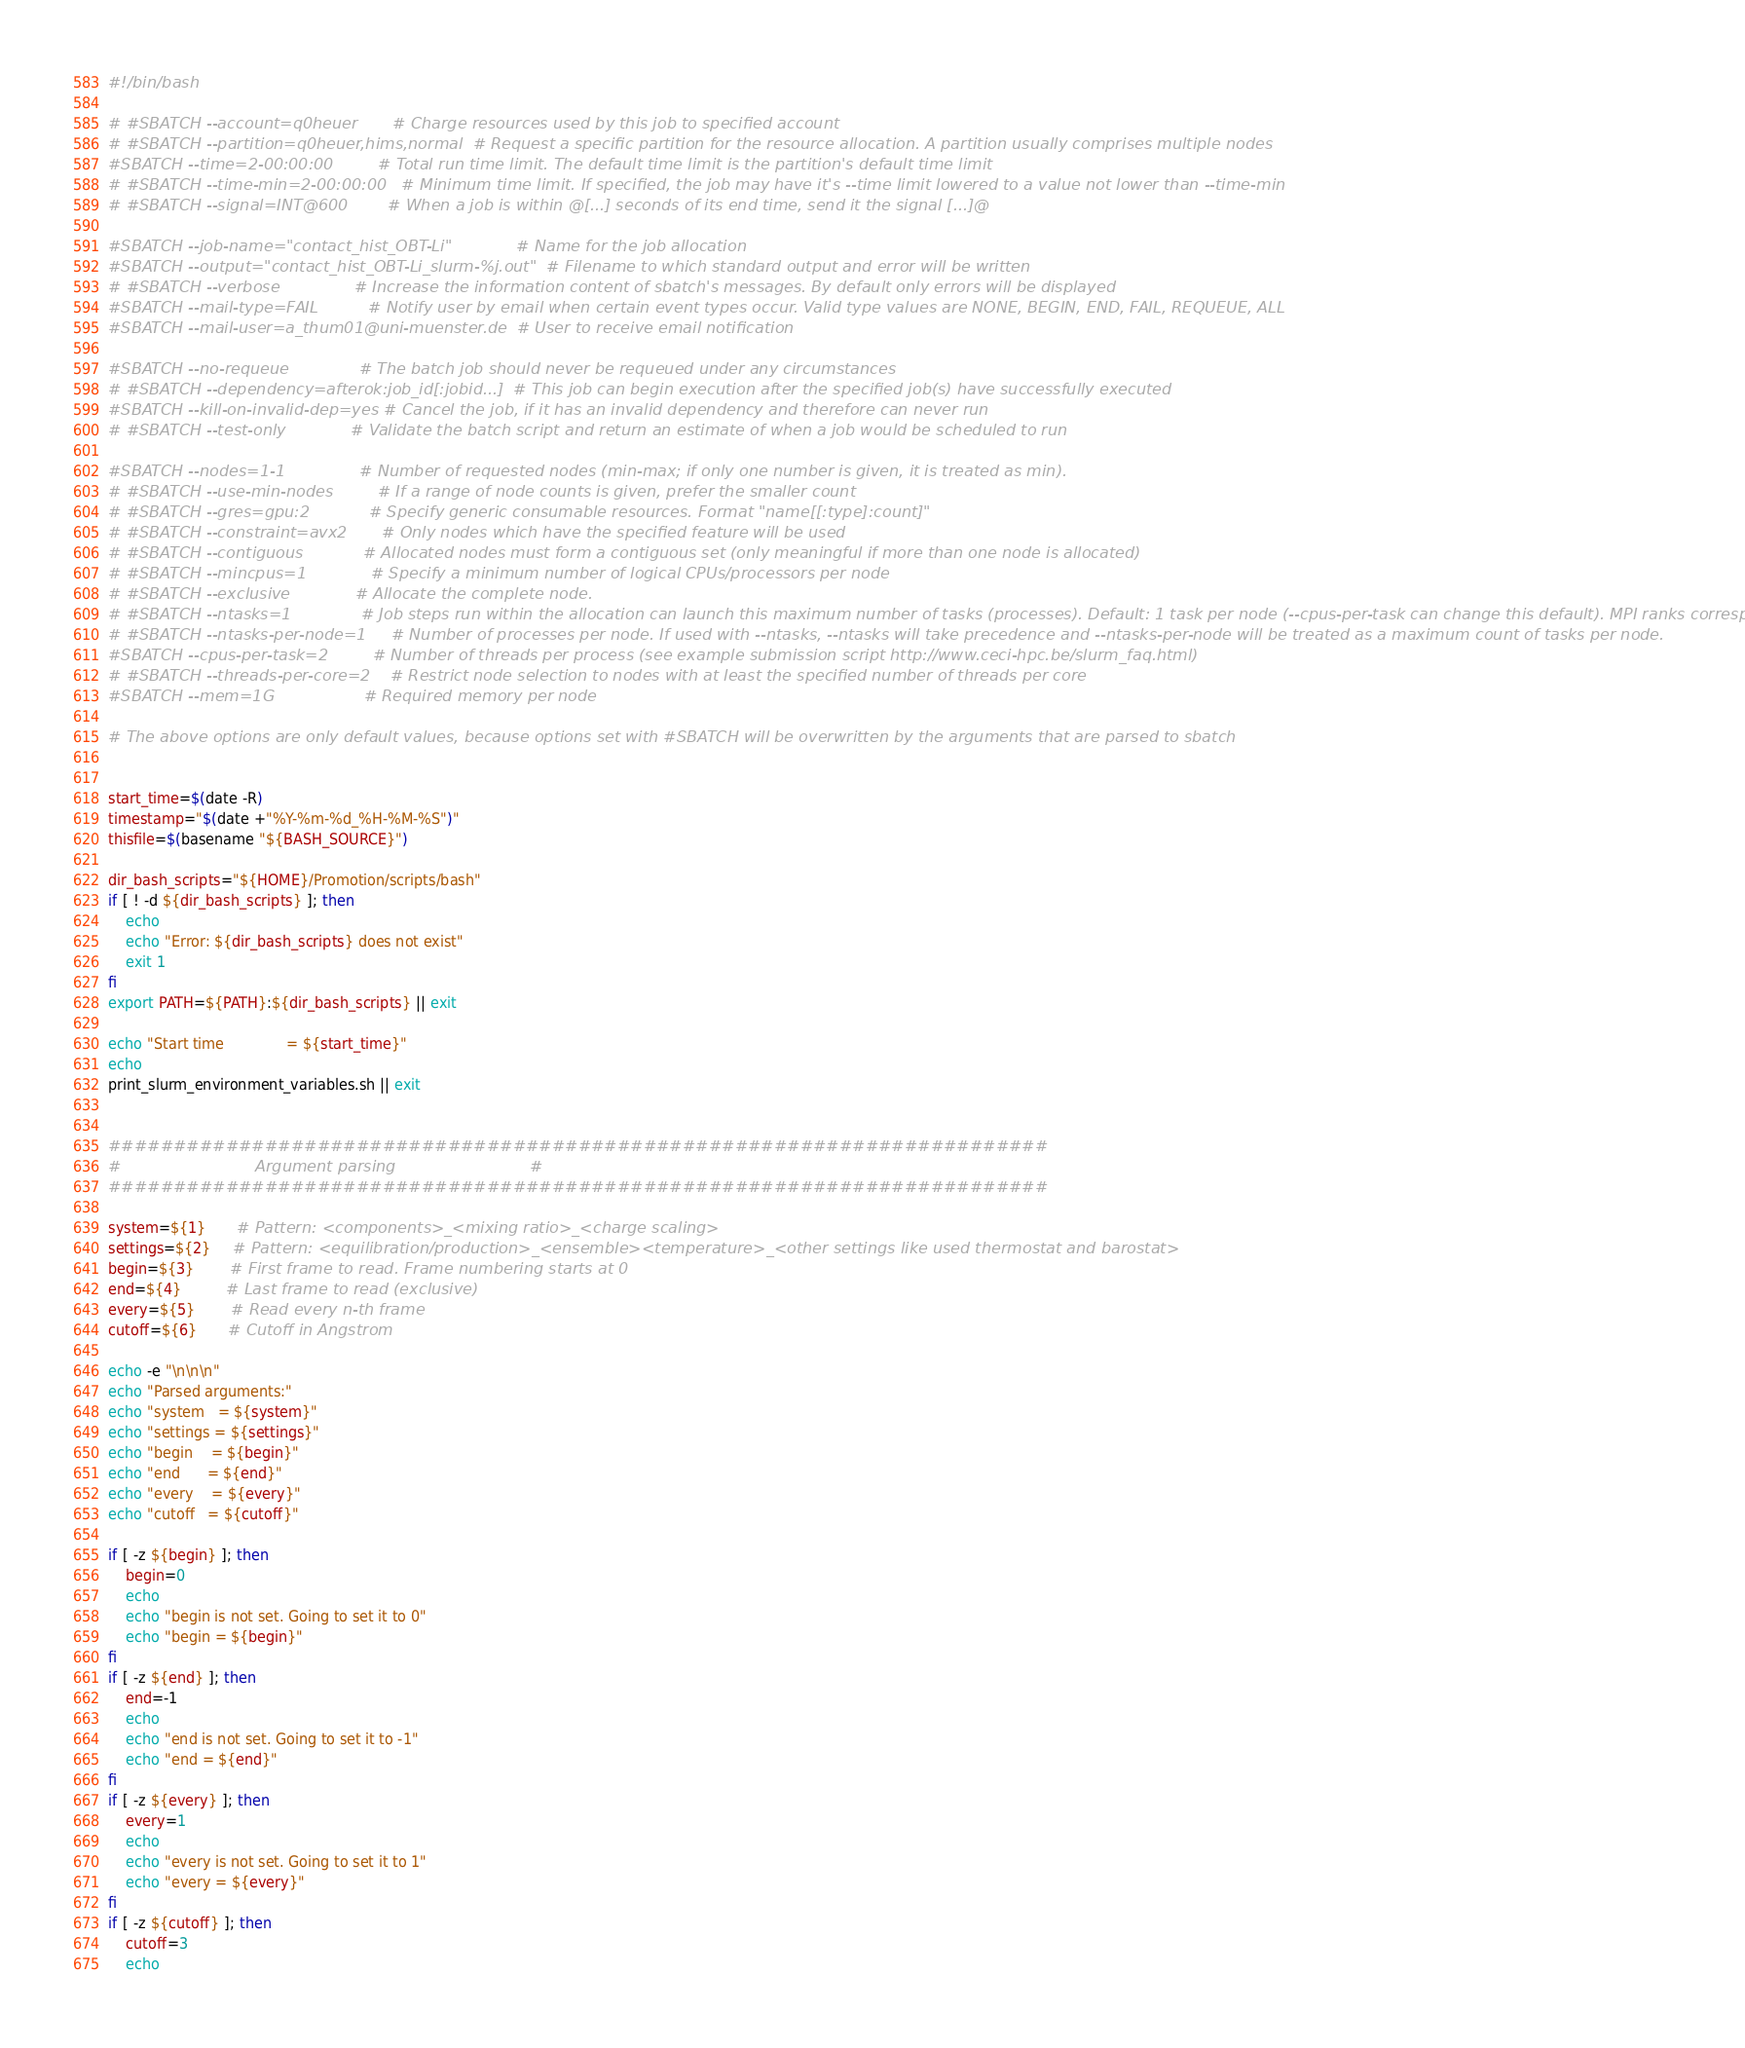<code> <loc_0><loc_0><loc_500><loc_500><_Bash_>#!/bin/bash

# #SBATCH --account=q0heuer       # Charge resources used by this job to specified account
# #SBATCH --partition=q0heuer,hims,normal  # Request a specific partition for the resource allocation. A partition usually comprises multiple nodes
#SBATCH --time=2-00:00:00         # Total run time limit. The default time limit is the partition's default time limit
# #SBATCH --time-min=2-00:00:00   # Minimum time limit. If specified, the job may have it's --time limit lowered to a value not lower than --time-min
# #SBATCH --signal=INT@600        # When a job is within @[...] seconds of its end time, send it the signal [...]@

#SBATCH --job-name="contact_hist_OBT-Li"             # Name for the job allocation
#SBATCH --output="contact_hist_OBT-Li_slurm-%j.out"  # Filename to which standard output and error will be written
# #SBATCH --verbose               # Increase the information content of sbatch's messages. By default only errors will be displayed
#SBATCH --mail-type=FAIL          # Notify user by email when certain event types occur. Valid type values are NONE, BEGIN, END, FAIL, REQUEUE, ALL
#SBATCH --mail-user=a_thum01@uni-muenster.de  # User to receive email notification

#SBATCH --no-requeue              # The batch job should never be requeued under any circumstances
# #SBATCH --dependency=afterok:job_id[:jobid...]  # This job can begin execution after the specified job(s) have successfully executed
#SBATCH --kill-on-invalid-dep=yes # Cancel the job, if it has an invalid dependency and therefore can never run
# #SBATCH --test-only             # Validate the batch script and return an estimate of when a job would be scheduled to run

#SBATCH --nodes=1-1               # Number of requested nodes (min-max; if only one number is given, it is treated as min).
# #SBATCH --use-min-nodes         # If a range of node counts is given, prefer the smaller count
# #SBATCH --gres=gpu:2            # Specify generic consumable resources. Format "name[[:type]:count]"
# #SBATCH --constraint=avx2       # Only nodes which have the specified feature will be used
# #SBATCH --contiguous            # Allocated nodes must form a contiguous set (only meaningful if more than one node is allocated)
# #SBATCH --mincpus=1             # Specify a minimum number of logical CPUs/processors per node
# #SBATCH --exclusive             # Allocate the complete node.
# #SBATCH --ntasks=1              # Job steps run within the allocation can launch this maximum number of tasks (processes). Default: 1 task per node (--cpus-per-task can change this default). MPI ranks correspond to tasks.
# #SBATCH --ntasks-per-node=1     # Number of processes per node. If used with --ntasks, --ntasks will take precedence and --ntasks-per-node will be treated as a maximum count of tasks per node.
#SBATCH --cpus-per-task=2         # Number of threads per process (see example submission script http://www.ceci-hpc.be/slurm_faq.html)
# #SBATCH --threads-per-core=2    # Restrict node selection to nodes with at least the specified number of threads per core
#SBATCH --mem=1G                  # Required memory per node

# The above options are only default values, because options set with #SBATCH will be overwritten by the arguments that are parsed to sbatch


start_time=$(date -R)
timestamp="$(date +"%Y-%m-%d_%H-%M-%S")"
thisfile=$(basename "${BASH_SOURCE}")

dir_bash_scripts="${HOME}/Promotion/scripts/bash"
if [ ! -d ${dir_bash_scripts} ]; then
    echo
    echo "Error: ${dir_bash_scripts} does not exist"
    exit 1
fi
export PATH=${PATH}:${dir_bash_scripts} || exit

echo "Start time              = ${start_time}"
echo
print_slurm_environment_variables.sh || exit


########################################################################
#                           Argument parsing                           #
########################################################################

system=${1}       # Pattern: <components>_<mixing ratio>_<charge scaling>
settings=${2}     # Pattern: <equilibration/production>_<ensemble><temperature>_<other settings like used thermostat and barostat>
begin=${3}        # First frame to read. Frame numbering starts at 0
end=${4}          # Last frame to read (exclusive)
every=${5}        # Read every n-th frame
cutoff=${6}       # Cutoff in Angstrom

echo -e "\n\n\n"
echo "Parsed arguments:"
echo "system   = ${system}"
echo "settings = ${settings}"
echo "begin    = ${begin}"
echo "end      = ${end}"
echo "every    = ${every}"
echo "cutoff   = ${cutoff}"

if [ -z ${begin} ]; then
    begin=0
    echo
    echo "begin is not set. Going to set it to 0"
    echo "begin = ${begin}"
fi
if [ -z ${end} ]; then
    end=-1
    echo
    echo "end is not set. Going to set it to -1"
    echo "end = ${end}"
fi
if [ -z ${every} ]; then
    every=1
    echo
    echo "every is not set. Going to set it to 1"
    echo "every = ${every}"
fi
if [ -z ${cutoff} ]; then
    cutoff=3
    echo</code> 